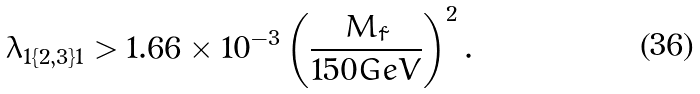Convert formula to latex. <formula><loc_0><loc_0><loc_500><loc_500>\lambda _ { 1 \{ 2 , 3 \} 1 } > 1 . 6 6 \times 1 0 ^ { - 3 } \left ( \frac { M _ { \tilde { f } } } { 1 5 0 G e V } \right ) ^ { 2 } .</formula> 